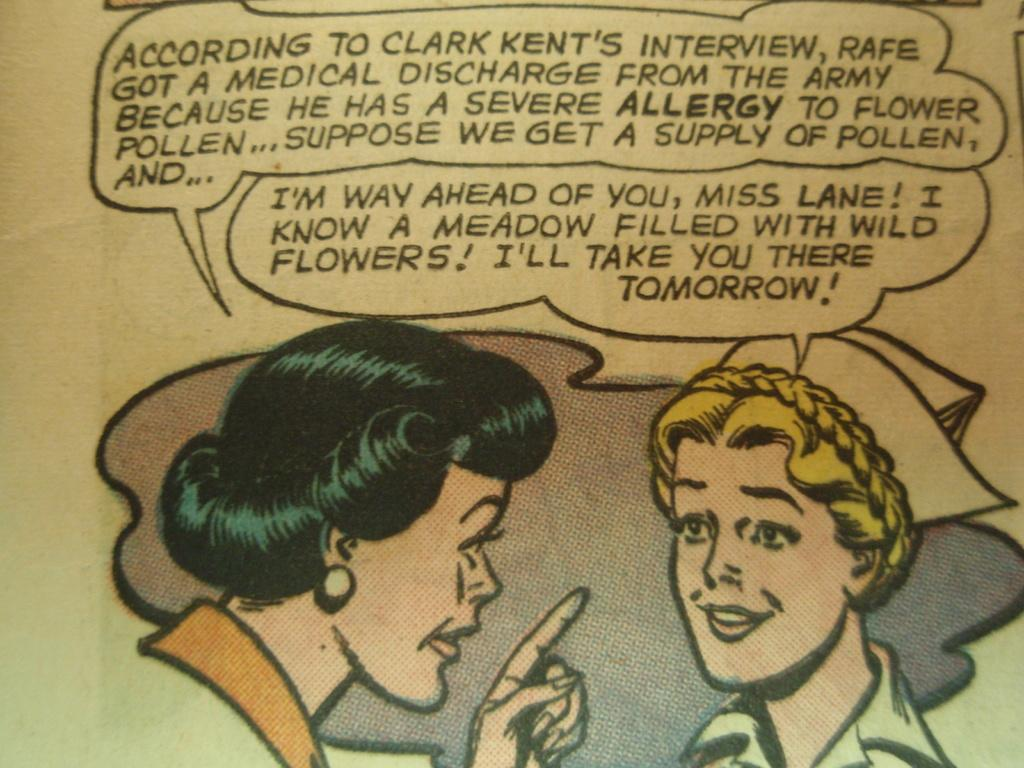What is the main subject of the image? The main subject of the image is a picture of two persons. Are there any words or letters in the image? Yes, there is text in the image. Where is the text located in the image? The text is at the top of the image. What else can be seen at the bottom of the image? There is a painting of two persons at the bottom of the image. How many toes can be seen on the monkey in the image? There is no monkey present in the image, so it is not possible to determine the number of toes. 